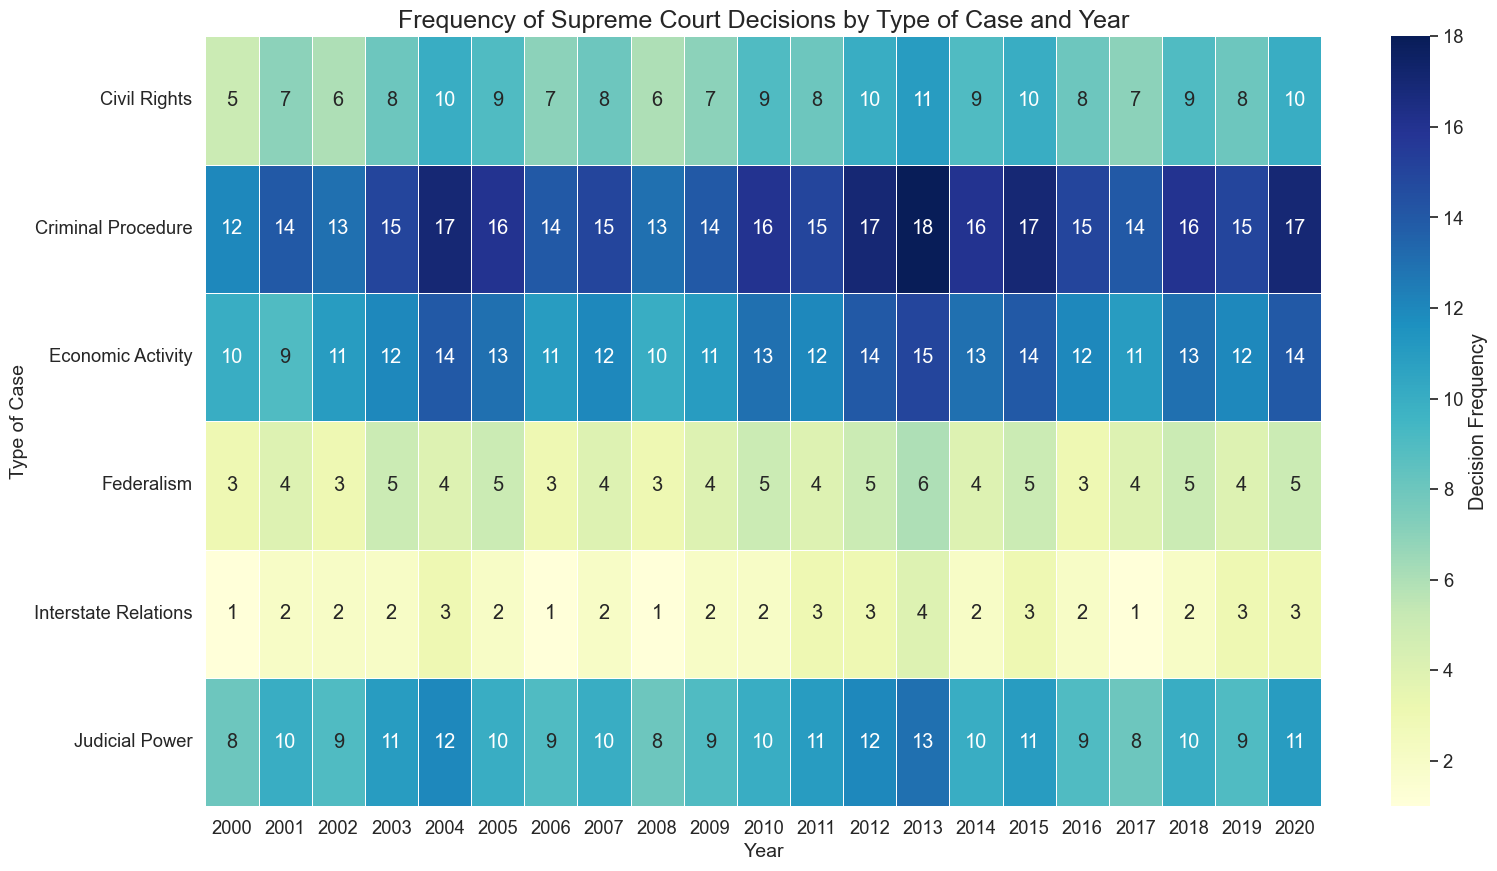What year had the highest frequency of Supreme Court decisions for Criminal Procedure cases? Observe the heatmap for the Criminal Procedure row and identify the year with the darkest shade or highest number.
Answer: 2013 Which type of case saw the most decisions in the year 2000? Look across the 2000 column to find the row with the highest frequency value.
Answer: Criminal Procedure In which year did Civil Rights cases have their peak frequency? Examine the Civil Rights row for the highest value and corresponding year.
Answer: 2013 Compare the frequency of Economic Activity cases in 2005 and 2010. Which year had more decisions? Compare the values in the Economic Activity row for the years 2005 and 2010 to see which is higher.
Answer: 2010 What is the total number of decisions for Federalism cases in all shown years? Sum the frequency values in the Federalism row across all years.
Answer: 67 What is the difference in the frequency of Judicial Power decisions between 2011 and 2012? Subtract the frequency value for 2011 from the frequency value for 2012 in the Judicial Power row.
Answer: 1 Which year had the lowest frequency of decisions for Interstate Relations cases? Identify the year with the smallest number in the Interstate Relations row.
Answer: 2000, 2006, 2017, 2008 Compare the frequency of Civil Rights decisions in 2007 with 2020. Which year had more decisions and by how much? Subtract the frequency in 2007 from the frequency in 2020 in the Civil Rights row.
Answer: 2020, by 2 decisions What is the average frequency of decisions for Economic Activity cases over the two decades shown? Sum all the values in the Economic Activity row and divide by the number of years (21).
Answer: 12 (rounded to the nearest whole number) Identify the type of case with the most consistent (least variation) frequency of decisions over the years. Visually inspect the heatmap rows for the similar shading or values, indicating minimal variation.
Answer: Judicial Power 